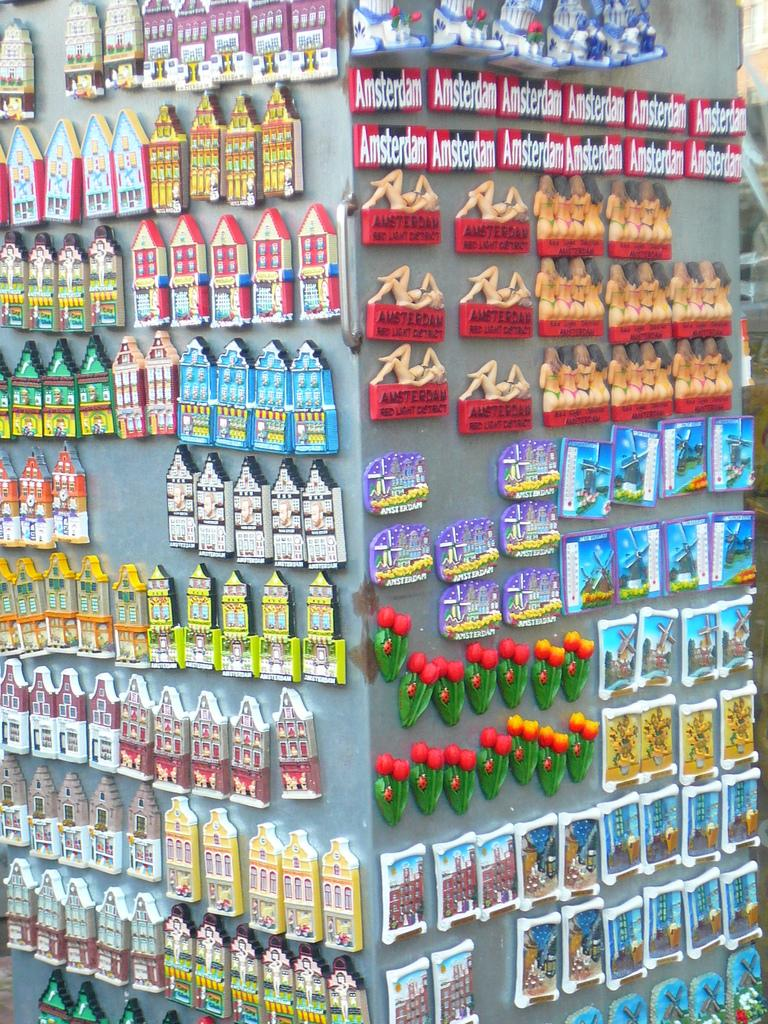<image>
Create a compact narrative representing the image presented. Store selling many keychains with one saying "Amsterdam". 